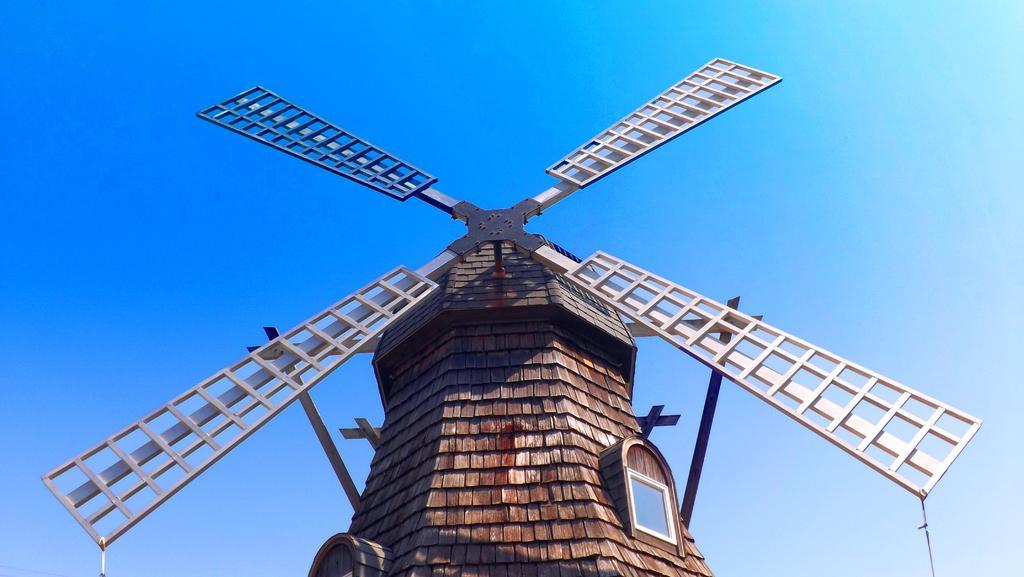Describe this image in one or two sentences. In this picture we can see a windmill in the front, there is the sky in the background. 